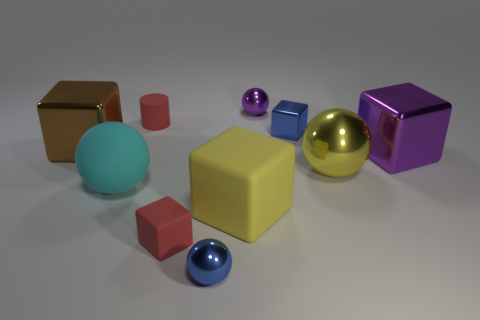Subtract all blue balls. How many balls are left? 3 Subtract all brown blocks. How many blocks are left? 4 Add 2 blue balls. How many blue balls are left? 3 Add 8 small blue metallic cylinders. How many small blue metallic cylinders exist? 8 Subtract 0 purple cylinders. How many objects are left? 10 Subtract all spheres. How many objects are left? 6 Subtract 2 spheres. How many spheres are left? 2 Subtract all yellow cylinders. Subtract all red balls. How many cylinders are left? 1 Subtract all blue cylinders. How many cyan balls are left? 1 Subtract all yellow metal balls. Subtract all small matte cubes. How many objects are left? 8 